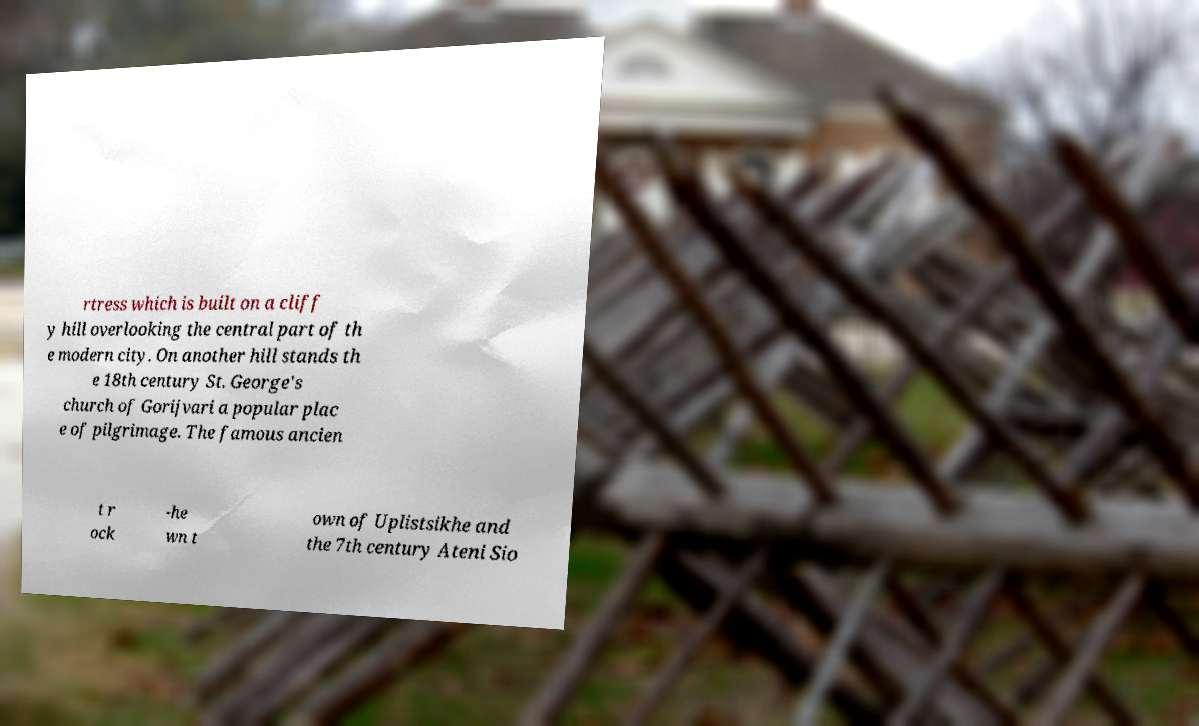Could you assist in decoding the text presented in this image and type it out clearly? rtress which is built on a cliff y hill overlooking the central part of th e modern city. On another hill stands th e 18th century St. George's church of Gorijvari a popular plac e of pilgrimage. The famous ancien t r ock -he wn t own of Uplistsikhe and the 7th century Ateni Sio 